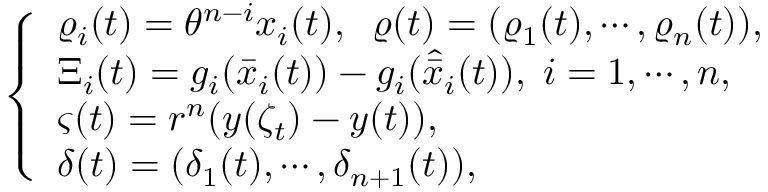<formula> <loc_0><loc_0><loc_500><loc_500>\left \{ \begin{array} { l } { \varrho _ { i } ( t ) = \theta ^ { n - i } x _ { i } ( t ) , \, \varrho ( t ) = ( \varrho _ { 1 } ( t ) , \cdots , \varrho _ { n } ( t ) ) , } \\ { \Xi _ { i } ( t ) = g _ { i } ( \bar { x } _ { i } ( t ) ) - g _ { i } ( \hat { \bar { x } } _ { i } ( t ) ) , \, i = 1 , \cdots , n , } \\ { \varsigma ( t ) = r ^ { n } ( y ( \zeta _ { t } ) - y ( t ) ) , } \\ { \delta ( t ) = ( \delta _ { 1 } ( t ) , \cdots , \delta _ { n + 1 } ( t ) ) , } \end{array}</formula> 